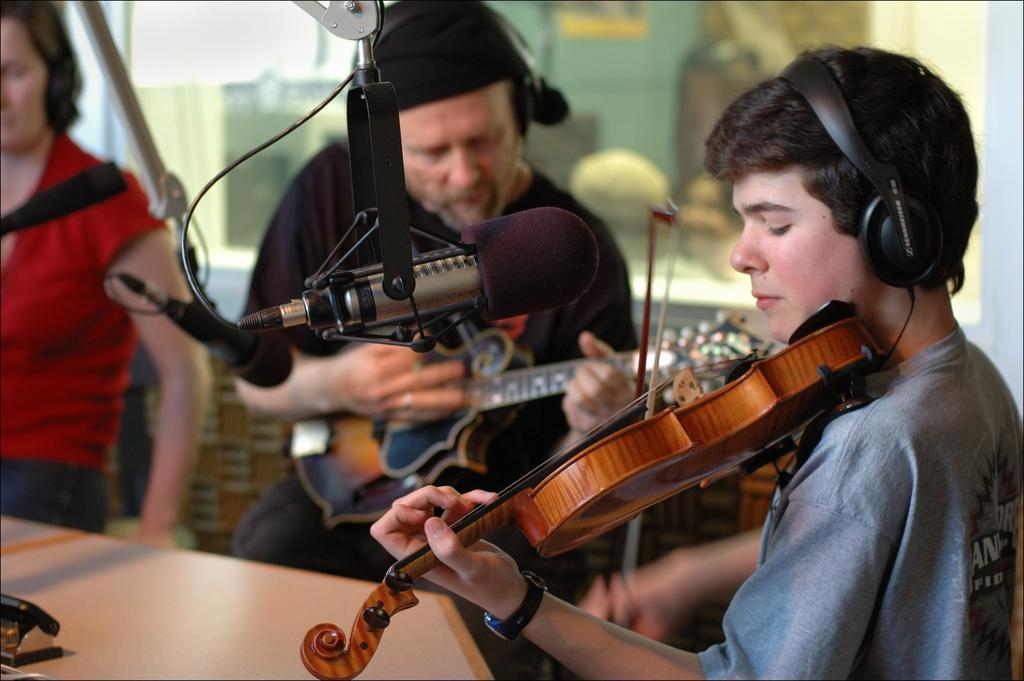How many people are in the image? There are three men in the image. What are two of the men doing in the image? Two of the men are holding musical instruments. What can be seen in front of the three men? All three men are standing in front of a microphone. What type of plantation can be seen growing in the army in the image? There is no army or plant present in the image; it features three men, two of whom are holding musical instruments, and all three are standing in front of a microphone. 